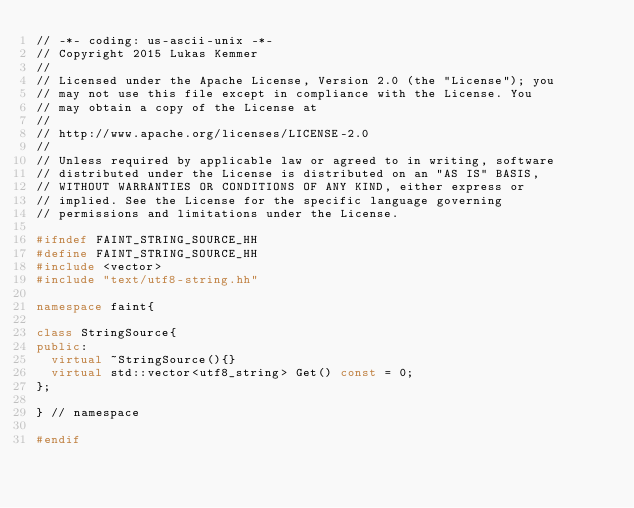Convert code to text. <code><loc_0><loc_0><loc_500><loc_500><_C++_>// -*- coding: us-ascii-unix -*-
// Copyright 2015 Lukas Kemmer
//
// Licensed under the Apache License, Version 2.0 (the "License"); you
// may not use this file except in compliance with the License. You
// may obtain a copy of the License at
//
// http://www.apache.org/licenses/LICENSE-2.0
//
// Unless required by applicable law or agreed to in writing, software
// distributed under the License is distributed on an "AS IS" BASIS,
// WITHOUT WARRANTIES OR CONDITIONS OF ANY KIND, either express or
// implied. See the License for the specific language governing
// permissions and limitations under the License.

#ifndef FAINT_STRING_SOURCE_HH
#define FAINT_STRING_SOURCE_HH
#include <vector>
#include "text/utf8-string.hh"

namespace faint{

class StringSource{
public:
  virtual ~StringSource(){}
  virtual std::vector<utf8_string> Get() const = 0;
};

} // namespace

#endif
</code> 